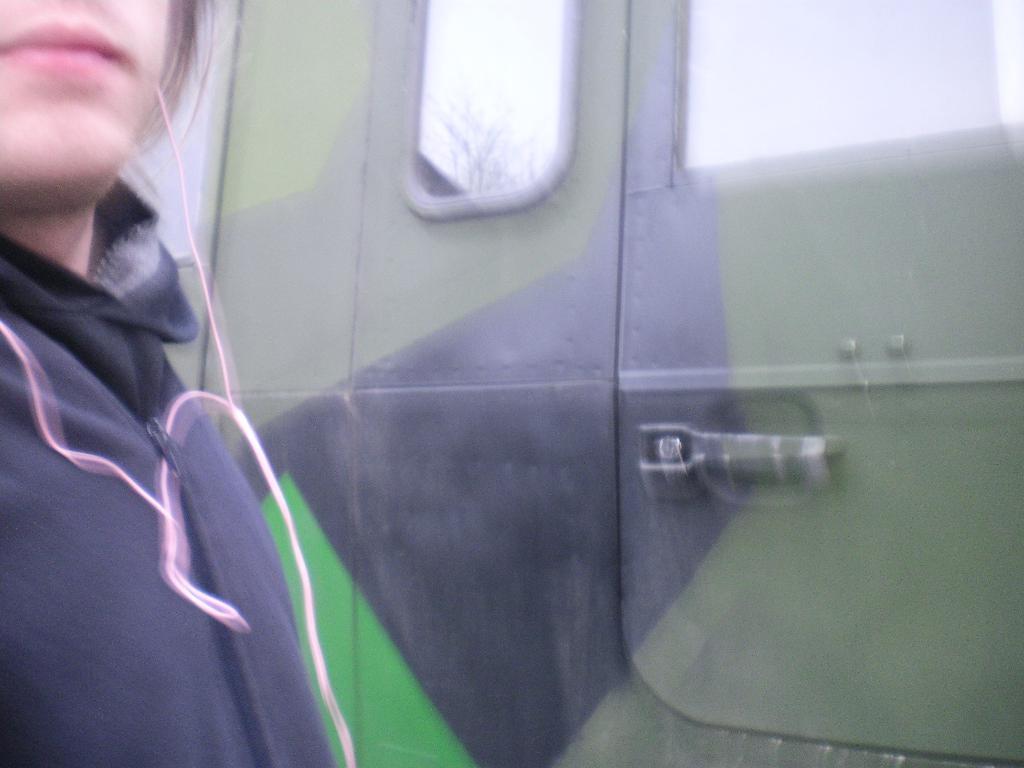Could you give a brief overview of what you see in this image? In this image, we can see a person and the door. 